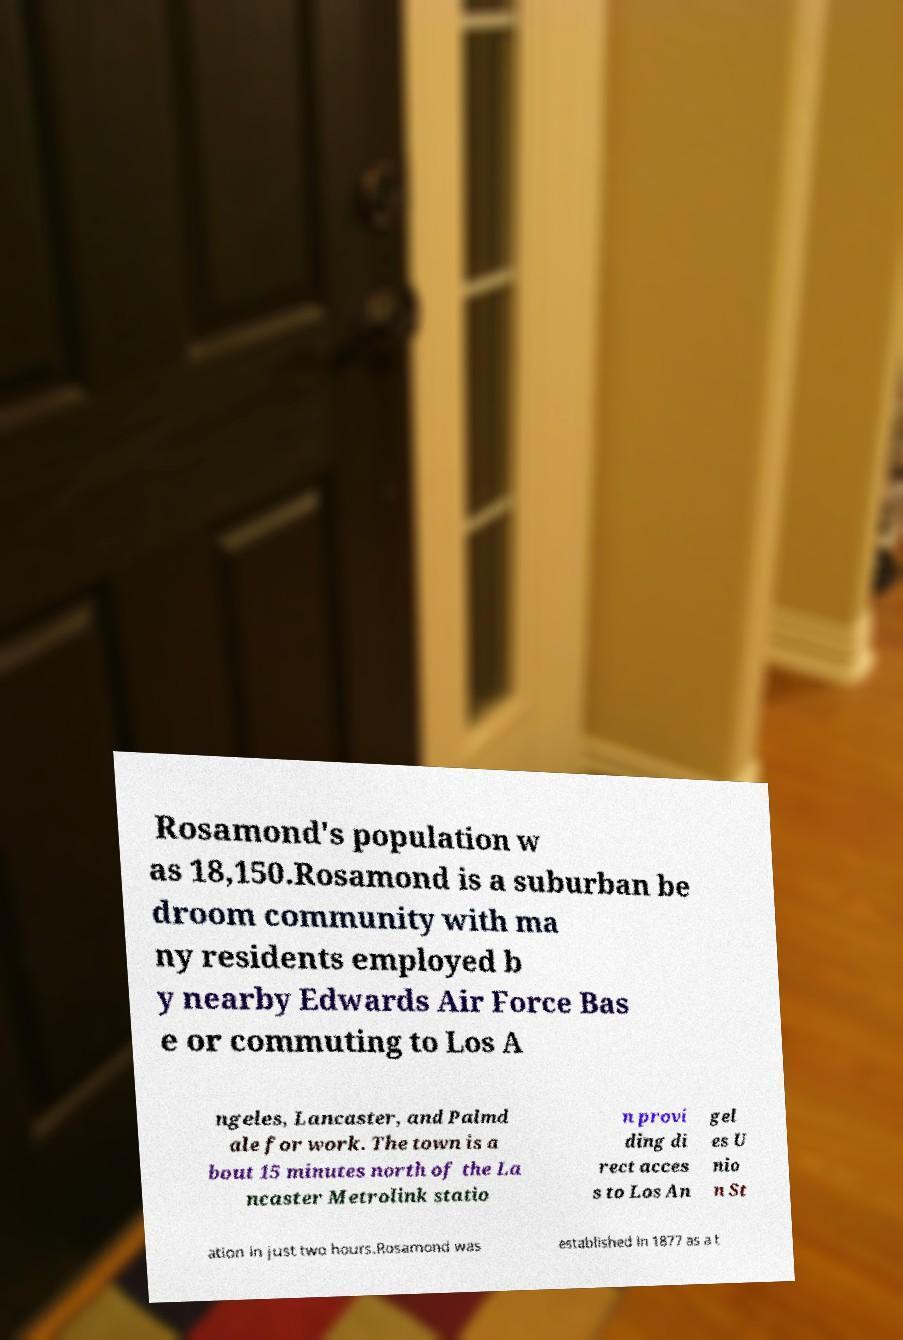Can you read and provide the text displayed in the image?This photo seems to have some interesting text. Can you extract and type it out for me? Rosamond's population w as 18,150.Rosamond is a suburban be droom community with ma ny residents employed b y nearby Edwards Air Force Bas e or commuting to Los A ngeles, Lancaster, and Palmd ale for work. The town is a bout 15 minutes north of the La ncaster Metrolink statio n provi ding di rect acces s to Los An gel es U nio n St ation in just two hours.Rosamond was established in 1877 as a t 